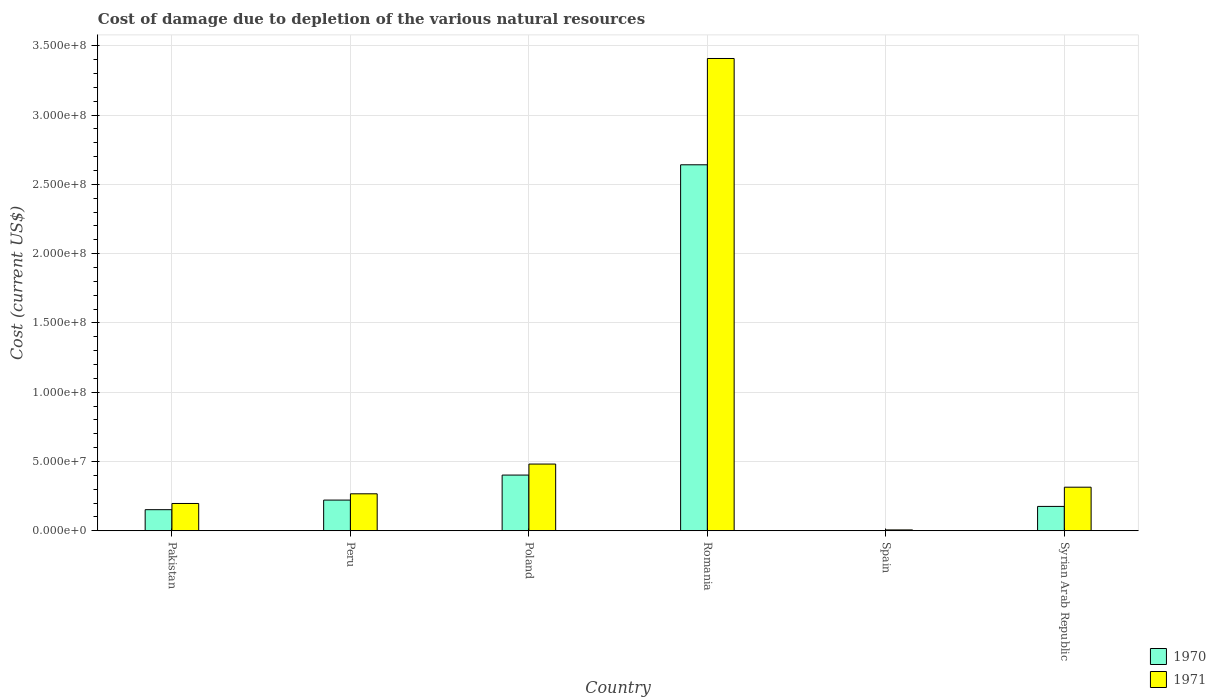How many groups of bars are there?
Ensure brevity in your answer.  6. Are the number of bars per tick equal to the number of legend labels?
Offer a very short reply. Yes. Are the number of bars on each tick of the X-axis equal?
Make the answer very short. Yes. How many bars are there on the 4th tick from the right?
Offer a terse response. 2. What is the label of the 1st group of bars from the left?
Make the answer very short. Pakistan. What is the cost of damage caused due to the depletion of various natural resources in 1970 in Syrian Arab Republic?
Your response must be concise. 1.76e+07. Across all countries, what is the maximum cost of damage caused due to the depletion of various natural resources in 1971?
Ensure brevity in your answer.  3.41e+08. Across all countries, what is the minimum cost of damage caused due to the depletion of various natural resources in 1970?
Provide a short and direct response. 1.78e+04. In which country was the cost of damage caused due to the depletion of various natural resources in 1970 maximum?
Ensure brevity in your answer.  Romania. What is the total cost of damage caused due to the depletion of various natural resources in 1970 in the graph?
Your answer should be compact. 3.59e+08. What is the difference between the cost of damage caused due to the depletion of various natural resources in 1970 in Peru and that in Poland?
Give a very brief answer. -1.80e+07. What is the difference between the cost of damage caused due to the depletion of various natural resources in 1970 in Pakistan and the cost of damage caused due to the depletion of various natural resources in 1971 in Spain?
Make the answer very short. 1.46e+07. What is the average cost of damage caused due to the depletion of various natural resources in 1971 per country?
Your response must be concise. 7.79e+07. What is the difference between the cost of damage caused due to the depletion of various natural resources of/in 1970 and cost of damage caused due to the depletion of various natural resources of/in 1971 in Pakistan?
Keep it short and to the point. -4.48e+06. What is the ratio of the cost of damage caused due to the depletion of various natural resources in 1970 in Pakistan to that in Poland?
Keep it short and to the point. 0.38. Is the cost of damage caused due to the depletion of various natural resources in 1971 in Peru less than that in Poland?
Your answer should be compact. Yes. What is the difference between the highest and the second highest cost of damage caused due to the depletion of various natural resources in 1970?
Offer a very short reply. -2.42e+08. What is the difference between the highest and the lowest cost of damage caused due to the depletion of various natural resources in 1971?
Your answer should be compact. 3.40e+08. In how many countries, is the cost of damage caused due to the depletion of various natural resources in 1971 greater than the average cost of damage caused due to the depletion of various natural resources in 1971 taken over all countries?
Your response must be concise. 1. Is the sum of the cost of damage caused due to the depletion of various natural resources in 1971 in Pakistan and Romania greater than the maximum cost of damage caused due to the depletion of various natural resources in 1970 across all countries?
Offer a very short reply. Yes. What does the 1st bar from the left in Peru represents?
Make the answer very short. 1970. Are all the bars in the graph horizontal?
Provide a succinct answer. No. How many countries are there in the graph?
Your answer should be very brief. 6. What is the difference between two consecutive major ticks on the Y-axis?
Provide a short and direct response. 5.00e+07. Does the graph contain any zero values?
Provide a succinct answer. No. Does the graph contain grids?
Your response must be concise. Yes. Where does the legend appear in the graph?
Keep it short and to the point. Bottom right. How many legend labels are there?
Make the answer very short. 2. How are the legend labels stacked?
Your answer should be compact. Vertical. What is the title of the graph?
Make the answer very short. Cost of damage due to depletion of the various natural resources. Does "2003" appear as one of the legend labels in the graph?
Make the answer very short. No. What is the label or title of the X-axis?
Provide a succinct answer. Country. What is the label or title of the Y-axis?
Offer a very short reply. Cost (current US$). What is the Cost (current US$) in 1970 in Pakistan?
Provide a succinct answer. 1.52e+07. What is the Cost (current US$) in 1971 in Pakistan?
Make the answer very short. 1.97e+07. What is the Cost (current US$) of 1970 in Peru?
Keep it short and to the point. 2.22e+07. What is the Cost (current US$) of 1971 in Peru?
Ensure brevity in your answer.  2.67e+07. What is the Cost (current US$) in 1970 in Poland?
Offer a terse response. 4.02e+07. What is the Cost (current US$) of 1971 in Poland?
Offer a very short reply. 4.82e+07. What is the Cost (current US$) in 1970 in Romania?
Your response must be concise. 2.64e+08. What is the Cost (current US$) in 1971 in Romania?
Provide a short and direct response. 3.41e+08. What is the Cost (current US$) in 1970 in Spain?
Provide a short and direct response. 1.78e+04. What is the Cost (current US$) in 1971 in Spain?
Your answer should be compact. 6.25e+05. What is the Cost (current US$) of 1970 in Syrian Arab Republic?
Provide a short and direct response. 1.76e+07. What is the Cost (current US$) of 1971 in Syrian Arab Republic?
Give a very brief answer. 3.14e+07. Across all countries, what is the maximum Cost (current US$) in 1970?
Your response must be concise. 2.64e+08. Across all countries, what is the maximum Cost (current US$) in 1971?
Your response must be concise. 3.41e+08. Across all countries, what is the minimum Cost (current US$) in 1970?
Give a very brief answer. 1.78e+04. Across all countries, what is the minimum Cost (current US$) of 1971?
Provide a succinct answer. 6.25e+05. What is the total Cost (current US$) in 1970 in the graph?
Keep it short and to the point. 3.59e+08. What is the total Cost (current US$) in 1971 in the graph?
Offer a terse response. 4.67e+08. What is the difference between the Cost (current US$) of 1970 in Pakistan and that in Peru?
Make the answer very short. -6.92e+06. What is the difference between the Cost (current US$) of 1971 in Pakistan and that in Peru?
Offer a terse response. -6.98e+06. What is the difference between the Cost (current US$) of 1970 in Pakistan and that in Poland?
Offer a terse response. -2.50e+07. What is the difference between the Cost (current US$) of 1971 in Pakistan and that in Poland?
Your answer should be compact. -2.84e+07. What is the difference between the Cost (current US$) of 1970 in Pakistan and that in Romania?
Keep it short and to the point. -2.49e+08. What is the difference between the Cost (current US$) of 1971 in Pakistan and that in Romania?
Your answer should be very brief. -3.21e+08. What is the difference between the Cost (current US$) of 1970 in Pakistan and that in Spain?
Give a very brief answer. 1.52e+07. What is the difference between the Cost (current US$) in 1971 in Pakistan and that in Spain?
Give a very brief answer. 1.91e+07. What is the difference between the Cost (current US$) in 1970 in Pakistan and that in Syrian Arab Republic?
Offer a terse response. -2.35e+06. What is the difference between the Cost (current US$) in 1971 in Pakistan and that in Syrian Arab Republic?
Offer a terse response. -1.17e+07. What is the difference between the Cost (current US$) of 1970 in Peru and that in Poland?
Offer a terse response. -1.80e+07. What is the difference between the Cost (current US$) in 1971 in Peru and that in Poland?
Your response must be concise. -2.15e+07. What is the difference between the Cost (current US$) of 1970 in Peru and that in Romania?
Your answer should be very brief. -2.42e+08. What is the difference between the Cost (current US$) of 1971 in Peru and that in Romania?
Give a very brief answer. -3.14e+08. What is the difference between the Cost (current US$) of 1970 in Peru and that in Spain?
Keep it short and to the point. 2.21e+07. What is the difference between the Cost (current US$) of 1971 in Peru and that in Spain?
Ensure brevity in your answer.  2.61e+07. What is the difference between the Cost (current US$) in 1970 in Peru and that in Syrian Arab Republic?
Give a very brief answer. 4.57e+06. What is the difference between the Cost (current US$) in 1971 in Peru and that in Syrian Arab Republic?
Your answer should be compact. -4.77e+06. What is the difference between the Cost (current US$) in 1970 in Poland and that in Romania?
Keep it short and to the point. -2.24e+08. What is the difference between the Cost (current US$) of 1971 in Poland and that in Romania?
Keep it short and to the point. -2.93e+08. What is the difference between the Cost (current US$) in 1970 in Poland and that in Spain?
Provide a succinct answer. 4.02e+07. What is the difference between the Cost (current US$) of 1971 in Poland and that in Spain?
Offer a terse response. 4.75e+07. What is the difference between the Cost (current US$) in 1970 in Poland and that in Syrian Arab Republic?
Provide a short and direct response. 2.26e+07. What is the difference between the Cost (current US$) in 1971 in Poland and that in Syrian Arab Republic?
Offer a terse response. 1.67e+07. What is the difference between the Cost (current US$) of 1970 in Romania and that in Spain?
Ensure brevity in your answer.  2.64e+08. What is the difference between the Cost (current US$) in 1971 in Romania and that in Spain?
Offer a very short reply. 3.40e+08. What is the difference between the Cost (current US$) in 1970 in Romania and that in Syrian Arab Republic?
Give a very brief answer. 2.47e+08. What is the difference between the Cost (current US$) of 1971 in Romania and that in Syrian Arab Republic?
Offer a terse response. 3.09e+08. What is the difference between the Cost (current US$) in 1970 in Spain and that in Syrian Arab Republic?
Make the answer very short. -1.76e+07. What is the difference between the Cost (current US$) of 1971 in Spain and that in Syrian Arab Republic?
Your answer should be compact. -3.08e+07. What is the difference between the Cost (current US$) in 1970 in Pakistan and the Cost (current US$) in 1971 in Peru?
Your response must be concise. -1.15e+07. What is the difference between the Cost (current US$) of 1970 in Pakistan and the Cost (current US$) of 1971 in Poland?
Your answer should be compact. -3.29e+07. What is the difference between the Cost (current US$) in 1970 in Pakistan and the Cost (current US$) in 1971 in Romania?
Ensure brevity in your answer.  -3.26e+08. What is the difference between the Cost (current US$) of 1970 in Pakistan and the Cost (current US$) of 1971 in Spain?
Your response must be concise. 1.46e+07. What is the difference between the Cost (current US$) of 1970 in Pakistan and the Cost (current US$) of 1971 in Syrian Arab Republic?
Offer a very short reply. -1.62e+07. What is the difference between the Cost (current US$) in 1970 in Peru and the Cost (current US$) in 1971 in Poland?
Offer a terse response. -2.60e+07. What is the difference between the Cost (current US$) in 1970 in Peru and the Cost (current US$) in 1971 in Romania?
Your answer should be very brief. -3.19e+08. What is the difference between the Cost (current US$) in 1970 in Peru and the Cost (current US$) in 1971 in Spain?
Your answer should be compact. 2.15e+07. What is the difference between the Cost (current US$) of 1970 in Peru and the Cost (current US$) of 1971 in Syrian Arab Republic?
Your answer should be very brief. -9.29e+06. What is the difference between the Cost (current US$) in 1970 in Poland and the Cost (current US$) in 1971 in Romania?
Give a very brief answer. -3.01e+08. What is the difference between the Cost (current US$) of 1970 in Poland and the Cost (current US$) of 1971 in Spain?
Offer a very short reply. 3.96e+07. What is the difference between the Cost (current US$) in 1970 in Poland and the Cost (current US$) in 1971 in Syrian Arab Republic?
Your answer should be very brief. 8.75e+06. What is the difference between the Cost (current US$) of 1970 in Romania and the Cost (current US$) of 1971 in Spain?
Give a very brief answer. 2.63e+08. What is the difference between the Cost (current US$) in 1970 in Romania and the Cost (current US$) in 1971 in Syrian Arab Republic?
Give a very brief answer. 2.33e+08. What is the difference between the Cost (current US$) in 1970 in Spain and the Cost (current US$) in 1971 in Syrian Arab Republic?
Ensure brevity in your answer.  -3.14e+07. What is the average Cost (current US$) of 1970 per country?
Your response must be concise. 5.99e+07. What is the average Cost (current US$) of 1971 per country?
Your answer should be very brief. 7.79e+07. What is the difference between the Cost (current US$) in 1970 and Cost (current US$) in 1971 in Pakistan?
Your response must be concise. -4.48e+06. What is the difference between the Cost (current US$) of 1970 and Cost (current US$) of 1971 in Peru?
Offer a very short reply. -4.53e+06. What is the difference between the Cost (current US$) of 1970 and Cost (current US$) of 1971 in Poland?
Keep it short and to the point. -7.95e+06. What is the difference between the Cost (current US$) of 1970 and Cost (current US$) of 1971 in Romania?
Give a very brief answer. -7.67e+07. What is the difference between the Cost (current US$) in 1970 and Cost (current US$) in 1971 in Spain?
Offer a terse response. -6.07e+05. What is the difference between the Cost (current US$) of 1970 and Cost (current US$) of 1971 in Syrian Arab Republic?
Make the answer very short. -1.39e+07. What is the ratio of the Cost (current US$) in 1970 in Pakistan to that in Peru?
Give a very brief answer. 0.69. What is the ratio of the Cost (current US$) of 1971 in Pakistan to that in Peru?
Your response must be concise. 0.74. What is the ratio of the Cost (current US$) of 1970 in Pakistan to that in Poland?
Your response must be concise. 0.38. What is the ratio of the Cost (current US$) of 1971 in Pakistan to that in Poland?
Offer a very short reply. 0.41. What is the ratio of the Cost (current US$) in 1970 in Pakistan to that in Romania?
Your answer should be very brief. 0.06. What is the ratio of the Cost (current US$) in 1971 in Pakistan to that in Romania?
Offer a very short reply. 0.06. What is the ratio of the Cost (current US$) in 1970 in Pakistan to that in Spain?
Keep it short and to the point. 856.12. What is the ratio of the Cost (current US$) in 1971 in Pakistan to that in Spain?
Your response must be concise. 31.53. What is the ratio of the Cost (current US$) in 1970 in Pakistan to that in Syrian Arab Republic?
Ensure brevity in your answer.  0.87. What is the ratio of the Cost (current US$) in 1971 in Pakistan to that in Syrian Arab Republic?
Provide a short and direct response. 0.63. What is the ratio of the Cost (current US$) of 1970 in Peru to that in Poland?
Provide a succinct answer. 0.55. What is the ratio of the Cost (current US$) of 1971 in Peru to that in Poland?
Provide a succinct answer. 0.55. What is the ratio of the Cost (current US$) in 1970 in Peru to that in Romania?
Provide a succinct answer. 0.08. What is the ratio of the Cost (current US$) in 1971 in Peru to that in Romania?
Your answer should be compact. 0.08. What is the ratio of the Cost (current US$) of 1970 in Peru to that in Spain?
Your answer should be very brief. 1245.27. What is the ratio of the Cost (current US$) of 1971 in Peru to that in Spain?
Make the answer very short. 42.69. What is the ratio of the Cost (current US$) of 1970 in Peru to that in Syrian Arab Republic?
Your response must be concise. 1.26. What is the ratio of the Cost (current US$) in 1971 in Peru to that in Syrian Arab Republic?
Your response must be concise. 0.85. What is the ratio of the Cost (current US$) in 1970 in Poland to that in Romania?
Offer a terse response. 0.15. What is the ratio of the Cost (current US$) in 1971 in Poland to that in Romania?
Your response must be concise. 0.14. What is the ratio of the Cost (current US$) in 1970 in Poland to that in Spain?
Your answer should be very brief. 2259.53. What is the ratio of the Cost (current US$) of 1971 in Poland to that in Spain?
Offer a terse response. 77.04. What is the ratio of the Cost (current US$) of 1970 in Poland to that in Syrian Arab Republic?
Make the answer very short. 2.29. What is the ratio of the Cost (current US$) of 1971 in Poland to that in Syrian Arab Republic?
Make the answer very short. 1.53. What is the ratio of the Cost (current US$) of 1970 in Romania to that in Spain?
Give a very brief answer. 1.48e+04. What is the ratio of the Cost (current US$) in 1971 in Romania to that in Spain?
Your answer should be very brief. 545.26. What is the ratio of the Cost (current US$) of 1970 in Romania to that in Syrian Arab Republic?
Offer a very short reply. 15.02. What is the ratio of the Cost (current US$) in 1971 in Romania to that in Syrian Arab Republic?
Make the answer very short. 10.84. What is the ratio of the Cost (current US$) in 1971 in Spain to that in Syrian Arab Republic?
Give a very brief answer. 0.02. What is the difference between the highest and the second highest Cost (current US$) of 1970?
Your answer should be compact. 2.24e+08. What is the difference between the highest and the second highest Cost (current US$) of 1971?
Your answer should be very brief. 2.93e+08. What is the difference between the highest and the lowest Cost (current US$) in 1970?
Ensure brevity in your answer.  2.64e+08. What is the difference between the highest and the lowest Cost (current US$) of 1971?
Provide a short and direct response. 3.40e+08. 